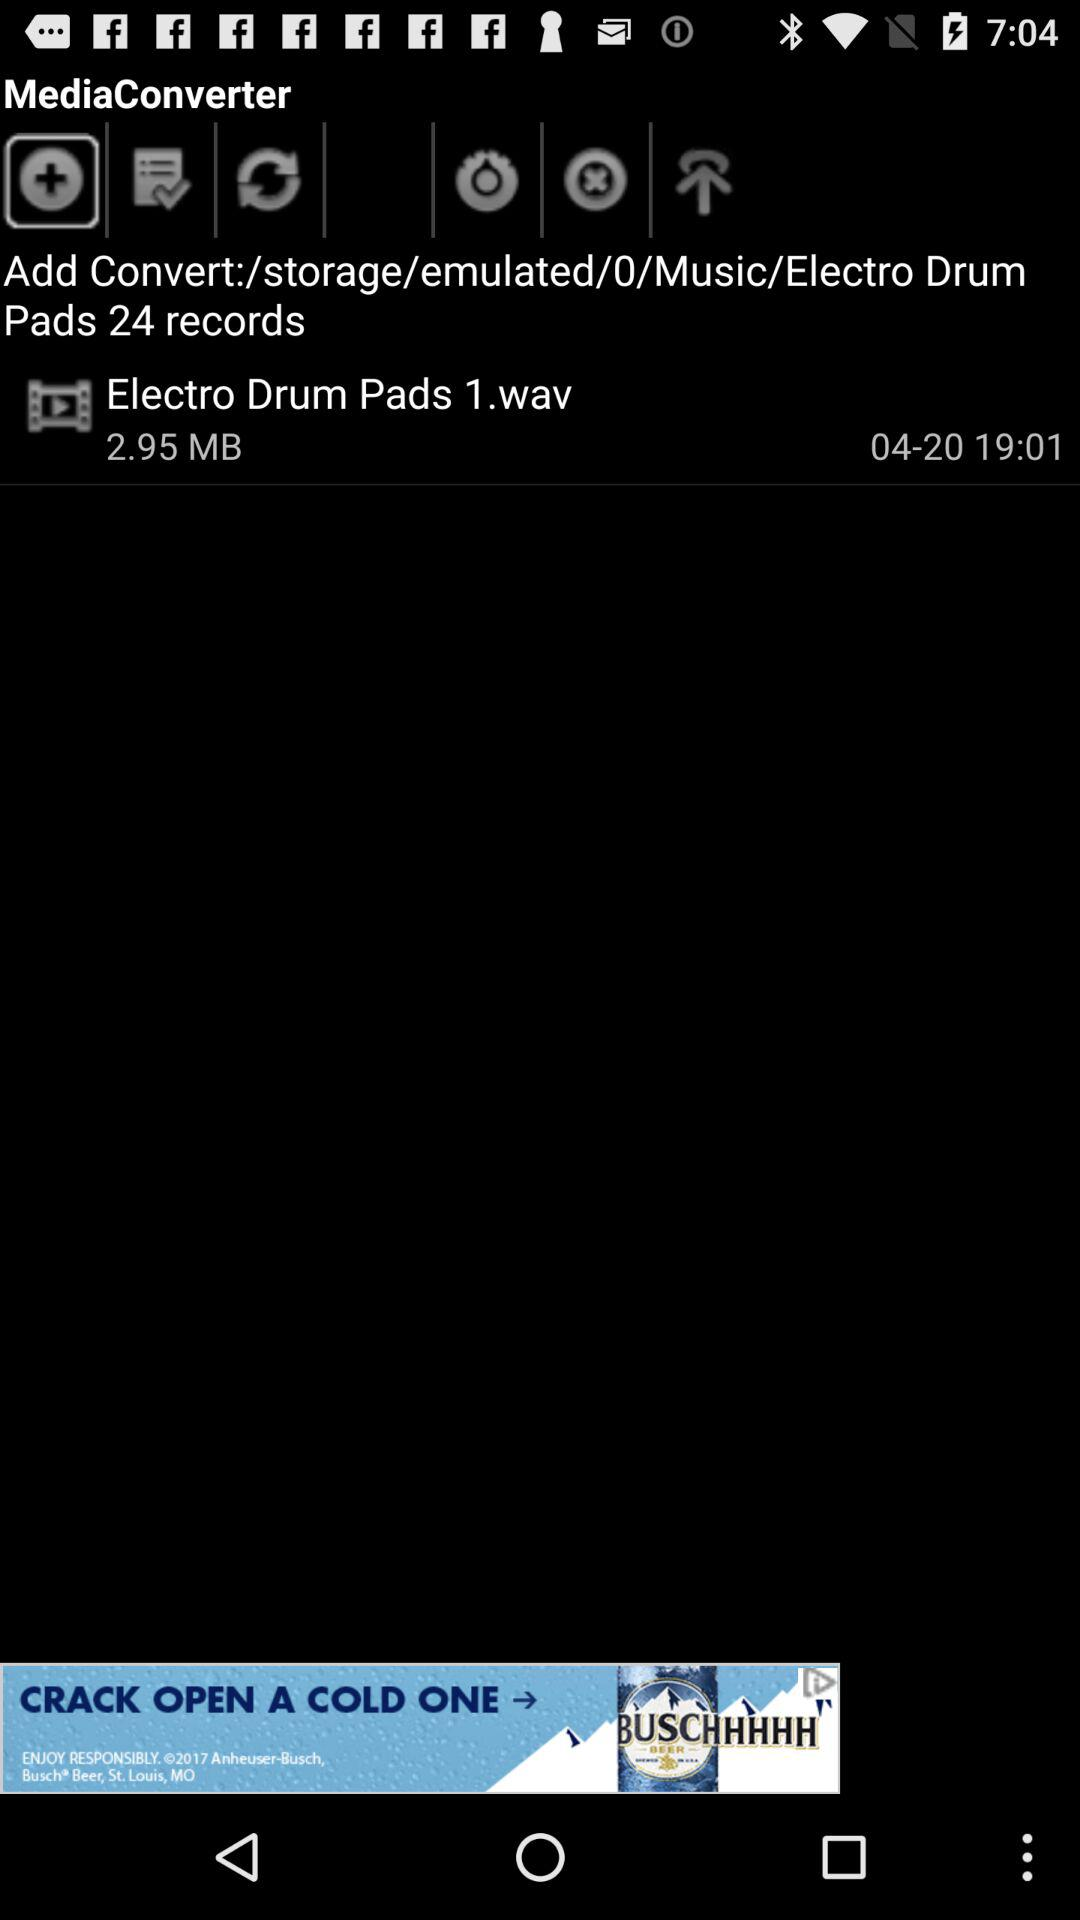What is the referenced date? The date is 04-20. 